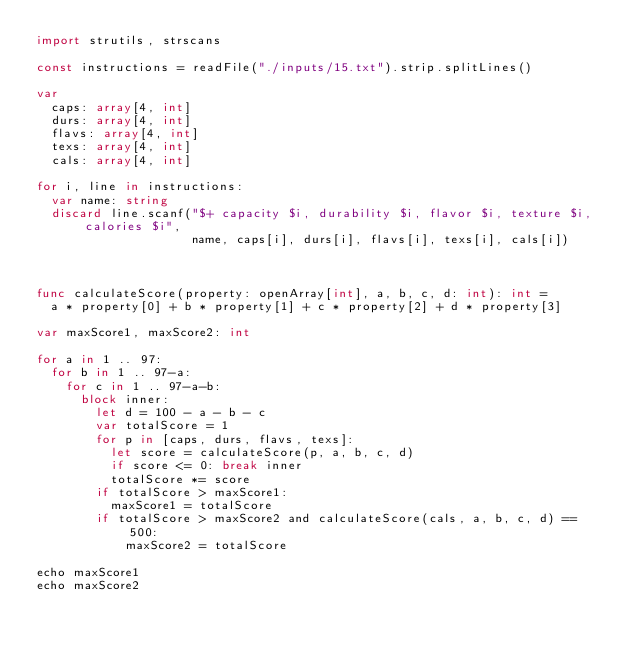Convert code to text. <code><loc_0><loc_0><loc_500><loc_500><_Nim_>import strutils, strscans

const instructions = readFile("./inputs/15.txt").strip.splitLines()

var
  caps: array[4, int]
  durs: array[4, int]
  flavs: array[4, int]
  texs: array[4, int]
  cals: array[4, int]

for i, line in instructions:
  var name: string
  discard line.scanf("$+ capacity $i, durability $i, flavor $i, texture $i, calories $i",
                     name, caps[i], durs[i], flavs[i], texs[i], cals[i])



func calculateScore(property: openArray[int], a, b, c, d: int): int =
  a * property[0] + b * property[1] + c * property[2] + d * property[3]

var maxScore1, maxScore2: int

for a in 1 .. 97:
  for b in 1 .. 97-a:
    for c in 1 .. 97-a-b:
      block inner:
        let d = 100 - a - b - c
        var totalScore = 1
        for p in [caps, durs, flavs, texs]:
          let score = calculateScore(p, a, b, c, d)
          if score <= 0: break inner
          totalScore *= score
        if totalScore > maxScore1:
          maxScore1 = totalScore
        if totalScore > maxScore2 and calculateScore(cals, a, b, c, d) == 500:
            maxScore2 = totalScore

echo maxScore1
echo maxScore2
</code> 